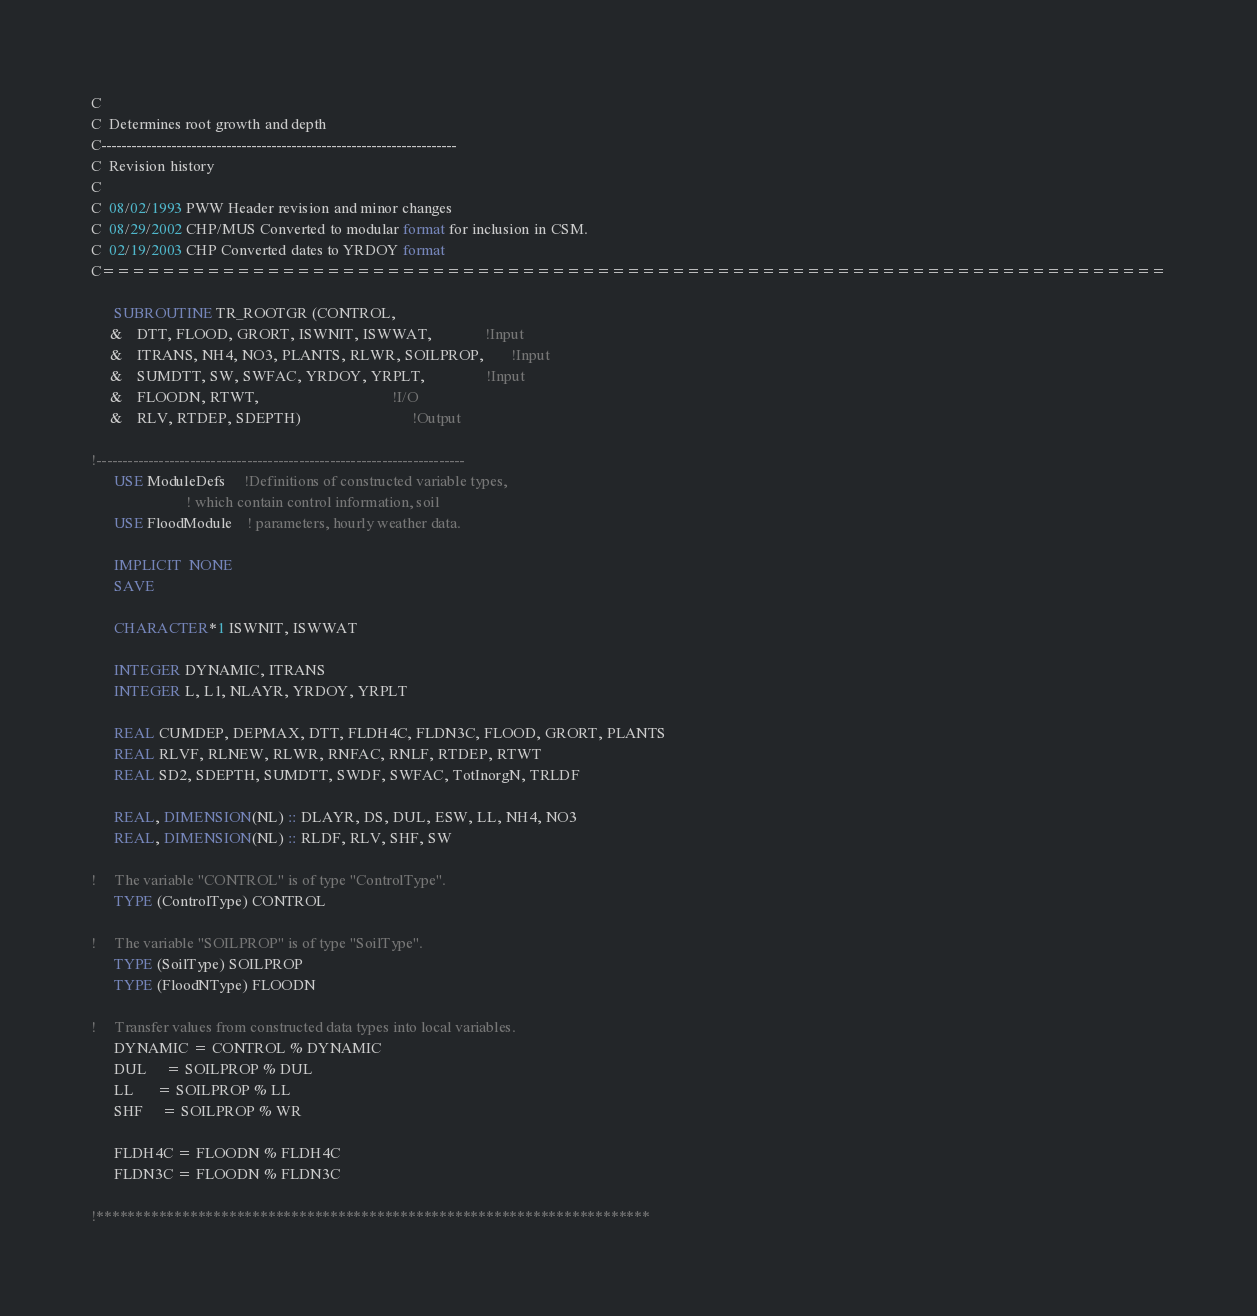<code> <loc_0><loc_0><loc_500><loc_500><_FORTRAN_>C
C  Determines root growth and depth
C-----------------------------------------------------------------------
C  Revision history
C
C  08/02/1993 PWW Header revision and minor changes
C  08/29/2002 CHP/MUS Converted to modular format for inclusion in CSM.
C  02/19/2003 CHP Converted dates to YRDOY format
C=======================================================================

      SUBROUTINE TR_ROOTGR (CONTROL, 
     &    DTT, FLOOD, GRORT, ISWNIT, ISWWAT,              !Input
     &    ITRANS, NH4, NO3, PLANTS, RLWR, SOILPROP,       !Input
     &    SUMDTT, SW, SWFAC, YRDOY, YRPLT,                !Input
     &    FLOODN, RTWT,                                   !I/O
     &    RLV, RTDEP, SDEPTH)                             !Output

!-----------------------------------------------------------------------
      USE ModuleDefs     !Definitions of constructed variable types, 
                         ! which contain control information, soil
      USE FloodModule    ! parameters, hourly weather data.

      IMPLICIT  NONE
      SAVE

      CHARACTER*1 ISWNIT, ISWWAT

      INTEGER DYNAMIC, ITRANS
      INTEGER L, L1, NLAYR, YRDOY, YRPLT

      REAL CUMDEP, DEPMAX, DTT, FLDH4C, FLDN3C, FLOOD, GRORT, PLANTS
      REAL RLVF, RLNEW, RLWR, RNFAC, RNLF, RTDEP, RTWT
      REAL SD2, SDEPTH, SUMDTT, SWDF, SWFAC, TotInorgN, TRLDF     

      REAL, DIMENSION(NL) :: DLAYR, DS, DUL, ESW, LL, NH4, NO3
      REAL, DIMENSION(NL) :: RLDF, RLV, SHF, SW

!     The variable "CONTROL" is of type "ControlType".
      TYPE (ControlType) CONTROL

!     The variable "SOILPROP" is of type "SoilType".
      TYPE (SoilType) SOILPROP
      TYPE (FloodNType) FLOODN

!     Transfer values from constructed data types into local variables.
      DYNAMIC = CONTROL % DYNAMIC
      DUL     = SOILPROP % DUL
      LL      = SOILPROP % LL
      SHF     = SOILPROP % WR

      FLDH4C = FLOODN % FLDH4C
      FLDN3C = FLOODN % FLDN3C
 
!***********************************************************************</code> 